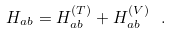Convert formula to latex. <formula><loc_0><loc_0><loc_500><loc_500>H _ { a b } = H _ { a b } ^ { ( T ) } + H _ { a b } ^ { ( V ) } \ .</formula> 